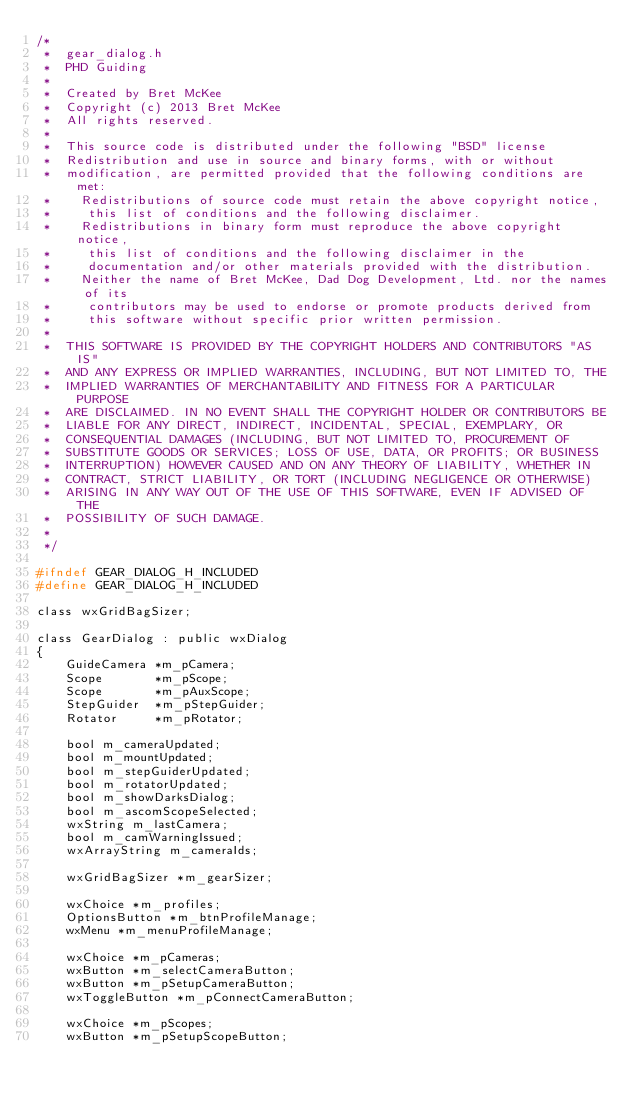Convert code to text. <code><loc_0><loc_0><loc_500><loc_500><_C_>/*
 *  gear_dialog.h
 *  PHD Guiding
 *
 *  Created by Bret McKee
 *  Copyright (c) 2013 Bret McKee
 *  All rights reserved.
 *
 *  This source code is distributed under the following "BSD" license
 *  Redistribution and use in source and binary forms, with or without
 *  modification, are permitted provided that the following conditions are met:
 *    Redistributions of source code must retain the above copyright notice,
 *     this list of conditions and the following disclaimer.
 *    Redistributions in binary form must reproduce the above copyright notice,
 *     this list of conditions and the following disclaimer in the
 *     documentation and/or other materials provided with the distribution.
 *    Neither the name of Bret McKee, Dad Dog Development, Ltd. nor the names of its
 *     contributors may be used to endorse or promote products derived from
 *     this software without specific prior written permission.
 *
 *  THIS SOFTWARE IS PROVIDED BY THE COPYRIGHT HOLDERS AND CONTRIBUTORS "AS IS"
 *  AND ANY EXPRESS OR IMPLIED WARRANTIES, INCLUDING, BUT NOT LIMITED TO, THE
 *  IMPLIED WARRANTIES OF MERCHANTABILITY AND FITNESS FOR A PARTICULAR PURPOSE
 *  ARE DISCLAIMED. IN NO EVENT SHALL THE COPYRIGHT HOLDER OR CONTRIBUTORS BE
 *  LIABLE FOR ANY DIRECT, INDIRECT, INCIDENTAL, SPECIAL, EXEMPLARY, OR
 *  CONSEQUENTIAL DAMAGES (INCLUDING, BUT NOT LIMITED TO, PROCUREMENT OF
 *  SUBSTITUTE GOODS OR SERVICES; LOSS OF USE, DATA, OR PROFITS; OR BUSINESS
 *  INTERRUPTION) HOWEVER CAUSED AND ON ANY THEORY OF LIABILITY, WHETHER IN
 *  CONTRACT, STRICT LIABILITY, OR TORT (INCLUDING NEGLIGENCE OR OTHERWISE)
 *  ARISING IN ANY WAY OUT OF THE USE OF THIS SOFTWARE, EVEN IF ADVISED OF THE
 *  POSSIBILITY OF SUCH DAMAGE.
 *
 */

#ifndef GEAR_DIALOG_H_INCLUDED
#define GEAR_DIALOG_H_INCLUDED

class wxGridBagSizer;

class GearDialog : public wxDialog
{
    GuideCamera *m_pCamera;
    Scope       *m_pScope;
    Scope       *m_pAuxScope;
    StepGuider  *m_pStepGuider;
    Rotator     *m_pRotator;

    bool m_cameraUpdated;
    bool m_mountUpdated;
    bool m_stepGuiderUpdated;
    bool m_rotatorUpdated;
    bool m_showDarksDialog;
    bool m_ascomScopeSelected;
    wxString m_lastCamera;
    bool m_camWarningIssued;
    wxArrayString m_cameraIds;

    wxGridBagSizer *m_gearSizer;

    wxChoice *m_profiles;
    OptionsButton *m_btnProfileManage;
    wxMenu *m_menuProfileManage;

    wxChoice *m_pCameras;
    wxButton *m_selectCameraButton;
    wxButton *m_pSetupCameraButton;
    wxToggleButton *m_pConnectCameraButton;

    wxChoice *m_pScopes;
    wxButton *m_pSetupScopeButton;</code> 